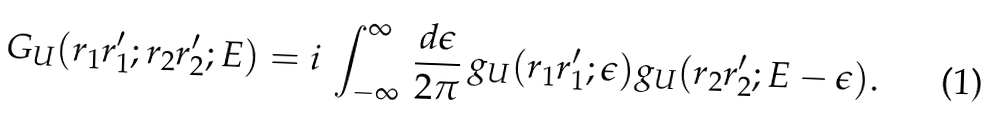Convert formula to latex. <formula><loc_0><loc_0><loc_500><loc_500>G _ { U } ( { r } _ { 1 } { r } ^ { \prime } _ { 1 } ; { r } _ { 2 } { r } ^ { \prime } _ { 2 } ; E ) = i \, \int ^ { \infty } _ { - \infty } \, \frac { d \epsilon } { 2 \pi } \, g _ { U } ( { r } _ { 1 } { r } ^ { \prime } _ { 1 } ; \epsilon ) g _ { U } ( { r } _ { 2 } { r } ^ { \prime } _ { 2 } ; E - \epsilon ) .</formula> 